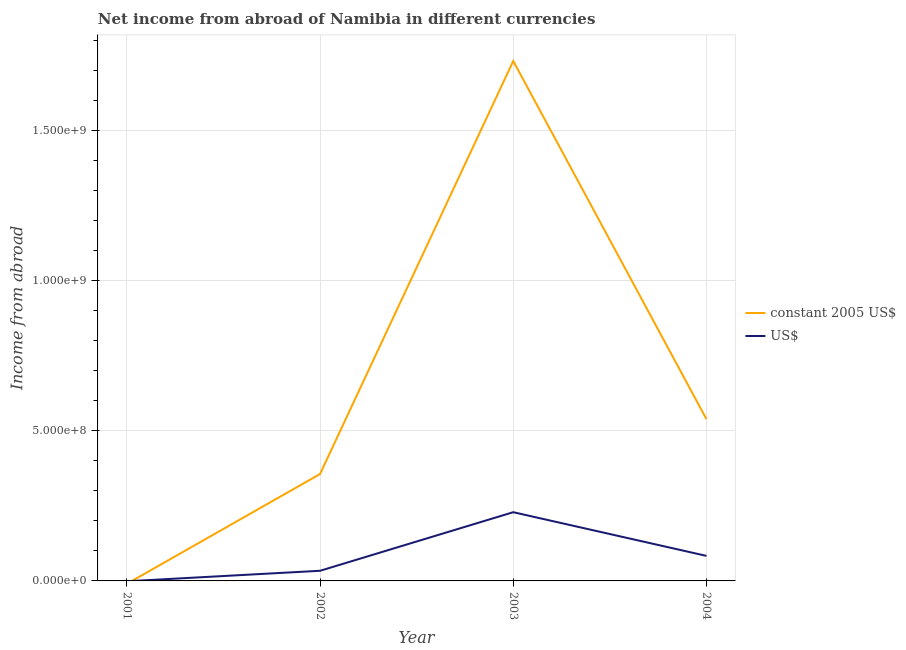How many different coloured lines are there?
Offer a very short reply. 2. Does the line corresponding to income from abroad in us$ intersect with the line corresponding to income from abroad in constant 2005 us$?
Your response must be concise. Yes. Is the number of lines equal to the number of legend labels?
Offer a terse response. No. What is the income from abroad in constant 2005 us$ in 2004?
Provide a short and direct response. 5.39e+08. Across all years, what is the maximum income from abroad in us$?
Your answer should be very brief. 2.29e+08. Across all years, what is the minimum income from abroad in us$?
Ensure brevity in your answer.  0. In which year was the income from abroad in constant 2005 us$ maximum?
Your answer should be compact. 2003. What is the total income from abroad in constant 2005 us$ in the graph?
Give a very brief answer. 2.63e+09. What is the difference between the income from abroad in constant 2005 us$ in 2003 and that in 2004?
Your answer should be compact. 1.19e+09. What is the difference between the income from abroad in constant 2005 us$ in 2001 and the income from abroad in us$ in 2002?
Your response must be concise. -3.38e+07. What is the average income from abroad in constant 2005 us$ per year?
Offer a very short reply. 6.57e+08. In the year 2003, what is the difference between the income from abroad in us$ and income from abroad in constant 2005 us$?
Provide a succinct answer. -1.50e+09. What is the ratio of the income from abroad in constant 2005 us$ in 2003 to that in 2004?
Your answer should be compact. 3.21. What is the difference between the highest and the second highest income from abroad in constant 2005 us$?
Your answer should be very brief. 1.19e+09. What is the difference between the highest and the lowest income from abroad in us$?
Make the answer very short. 2.29e+08. In how many years, is the income from abroad in us$ greater than the average income from abroad in us$ taken over all years?
Make the answer very short. 1. Does the income from abroad in constant 2005 us$ monotonically increase over the years?
Make the answer very short. No. Is the income from abroad in constant 2005 us$ strictly greater than the income from abroad in us$ over the years?
Give a very brief answer. No. Is the income from abroad in us$ strictly less than the income from abroad in constant 2005 us$ over the years?
Provide a succinct answer. No. How many lines are there?
Ensure brevity in your answer.  2. How many legend labels are there?
Your answer should be very brief. 2. How are the legend labels stacked?
Ensure brevity in your answer.  Vertical. What is the title of the graph?
Offer a terse response. Net income from abroad of Namibia in different currencies. Does "Private credit bureau" appear as one of the legend labels in the graph?
Your answer should be compact. No. What is the label or title of the Y-axis?
Make the answer very short. Income from abroad. What is the Income from abroad in constant 2005 US$ in 2001?
Your answer should be very brief. 0. What is the Income from abroad in US$ in 2001?
Give a very brief answer. 0. What is the Income from abroad in constant 2005 US$ in 2002?
Make the answer very short. 3.56e+08. What is the Income from abroad in US$ in 2002?
Keep it short and to the point. 3.38e+07. What is the Income from abroad of constant 2005 US$ in 2003?
Offer a very short reply. 1.73e+09. What is the Income from abroad of US$ in 2003?
Keep it short and to the point. 2.29e+08. What is the Income from abroad of constant 2005 US$ in 2004?
Keep it short and to the point. 5.39e+08. What is the Income from abroad in US$ in 2004?
Offer a terse response. 8.34e+07. Across all years, what is the maximum Income from abroad of constant 2005 US$?
Your response must be concise. 1.73e+09. Across all years, what is the maximum Income from abroad in US$?
Ensure brevity in your answer.  2.29e+08. What is the total Income from abroad in constant 2005 US$ in the graph?
Your answer should be very brief. 2.63e+09. What is the total Income from abroad of US$ in the graph?
Provide a short and direct response. 3.46e+08. What is the difference between the Income from abroad of constant 2005 US$ in 2002 and that in 2003?
Your answer should be very brief. -1.38e+09. What is the difference between the Income from abroad in US$ in 2002 and that in 2003?
Your response must be concise. -1.95e+08. What is the difference between the Income from abroad in constant 2005 US$ in 2002 and that in 2004?
Keep it short and to the point. -1.83e+08. What is the difference between the Income from abroad of US$ in 2002 and that in 2004?
Ensure brevity in your answer.  -4.96e+07. What is the difference between the Income from abroad in constant 2005 US$ in 2003 and that in 2004?
Ensure brevity in your answer.  1.19e+09. What is the difference between the Income from abroad of US$ in 2003 and that in 2004?
Your response must be concise. 1.46e+08. What is the difference between the Income from abroad of constant 2005 US$ in 2002 and the Income from abroad of US$ in 2003?
Provide a short and direct response. 1.27e+08. What is the difference between the Income from abroad in constant 2005 US$ in 2002 and the Income from abroad in US$ in 2004?
Your response must be concise. 2.73e+08. What is the difference between the Income from abroad in constant 2005 US$ in 2003 and the Income from abroad in US$ in 2004?
Your answer should be compact. 1.65e+09. What is the average Income from abroad in constant 2005 US$ per year?
Offer a terse response. 6.57e+08. What is the average Income from abroad in US$ per year?
Offer a very short reply. 8.65e+07. In the year 2002, what is the difference between the Income from abroad in constant 2005 US$ and Income from abroad in US$?
Provide a succinct answer. 3.22e+08. In the year 2003, what is the difference between the Income from abroad of constant 2005 US$ and Income from abroad of US$?
Give a very brief answer. 1.50e+09. In the year 2004, what is the difference between the Income from abroad of constant 2005 US$ and Income from abroad of US$?
Give a very brief answer. 4.55e+08. What is the ratio of the Income from abroad of constant 2005 US$ in 2002 to that in 2003?
Keep it short and to the point. 0.21. What is the ratio of the Income from abroad of US$ in 2002 to that in 2003?
Your answer should be very brief. 0.15. What is the ratio of the Income from abroad of constant 2005 US$ in 2002 to that in 2004?
Ensure brevity in your answer.  0.66. What is the ratio of the Income from abroad of US$ in 2002 to that in 2004?
Provide a succinct answer. 0.41. What is the ratio of the Income from abroad of constant 2005 US$ in 2003 to that in 2004?
Ensure brevity in your answer.  3.21. What is the ratio of the Income from abroad in US$ in 2003 to that in 2004?
Provide a short and direct response. 2.74. What is the difference between the highest and the second highest Income from abroad of constant 2005 US$?
Make the answer very short. 1.19e+09. What is the difference between the highest and the second highest Income from abroad of US$?
Your response must be concise. 1.46e+08. What is the difference between the highest and the lowest Income from abroad in constant 2005 US$?
Your answer should be very brief. 1.73e+09. What is the difference between the highest and the lowest Income from abroad of US$?
Offer a very short reply. 2.29e+08. 